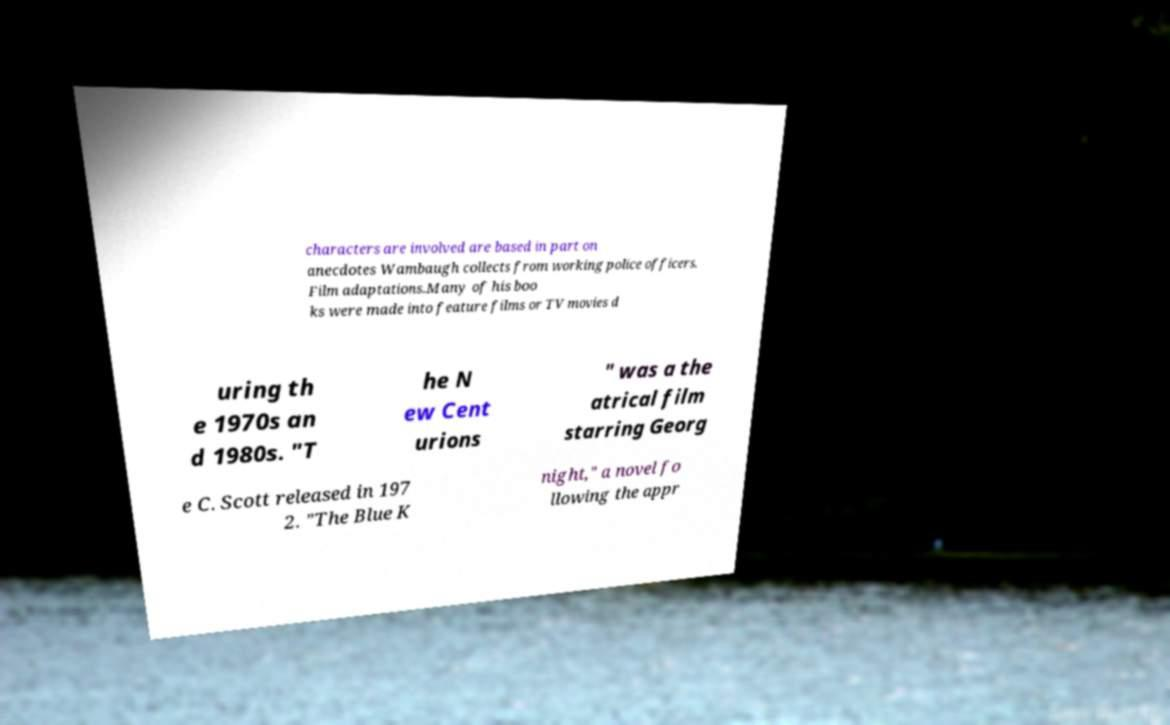Can you read and provide the text displayed in the image?This photo seems to have some interesting text. Can you extract and type it out for me? characters are involved are based in part on anecdotes Wambaugh collects from working police officers. Film adaptations.Many of his boo ks were made into feature films or TV movies d uring th e 1970s an d 1980s. "T he N ew Cent urions " was a the atrical film starring Georg e C. Scott released in 197 2. "The Blue K night," a novel fo llowing the appr 